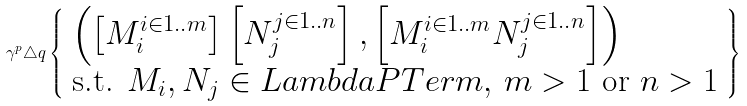Convert formula to latex. <formula><loc_0><loc_0><loc_500><loc_500>\gamma ^ { p } \triangle q \left \{ \begin{array} { l } \left ( \left [ M _ { i } ^ { i \in 1 . . m } \right ] \left [ N _ { j } ^ { j \in 1 . . n } \right ] , \left [ M _ { i } ^ { i \in 1 . . m } N _ { j } ^ { j \in 1 . . n } \right ] \right ) \\ \text {s.t. } M _ { i } , N _ { j } \in L a m b d a P T e r m , \, m > 1 \text { or } n > 1 \end{array} \right \}</formula> 